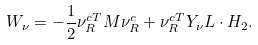Convert formula to latex. <formula><loc_0><loc_0><loc_500><loc_500>W _ { \nu } = - \frac { 1 } { 2 } \nu _ { R } ^ { c T } M \nu _ { R } ^ { c } + \nu _ { R } ^ { c T } Y _ { \nu } L \cdot H _ { 2 } .</formula> 